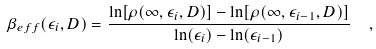Convert formula to latex. <formula><loc_0><loc_0><loc_500><loc_500>\beta _ { e f f } ( \epsilon _ { i } , D ) = \frac { \ln [ \rho ( \infty , \epsilon _ { i } , D ) ] - \ln [ \rho ( \infty , \epsilon _ { i - 1 } , D ) ] } { \ln ( \epsilon _ { i } ) - \ln ( \epsilon _ { i - 1 } ) } \ \ ,</formula> 